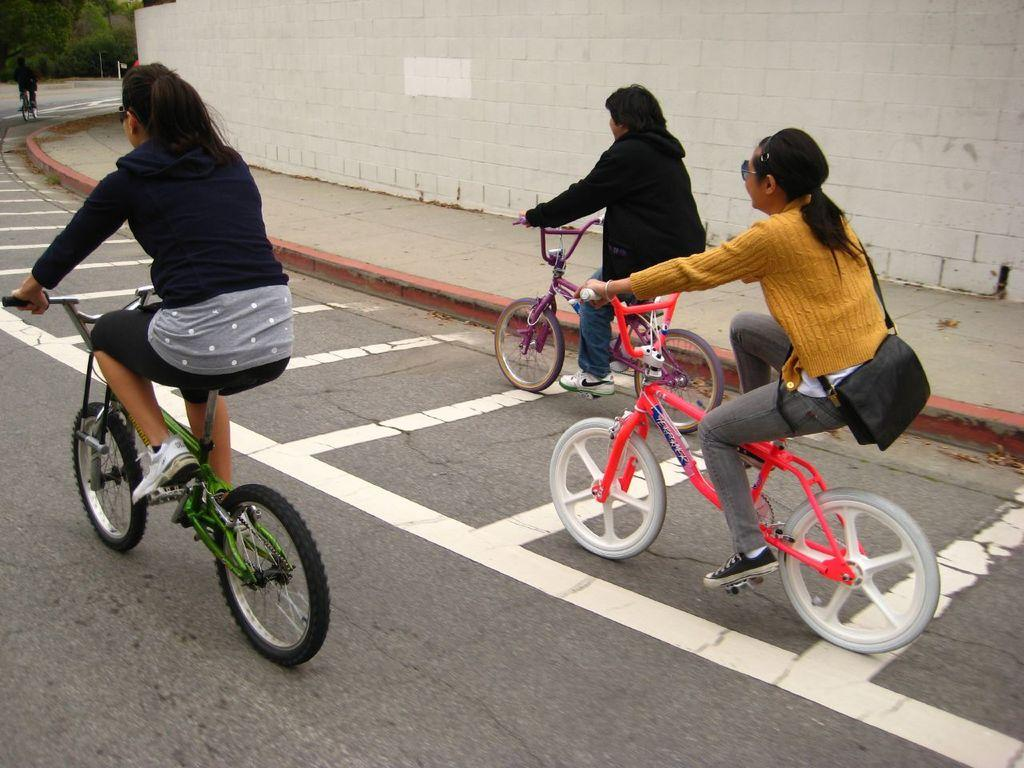How many people are on the bicycle in the image? There are three persons on the bicycle in the image. What is one of the persons doing while on the bicycle? One of the persons is carrying a bag. What type of surface can be seen in the image? There is a road in the image. What other structure is visible in the image? There is a wall in the image. What is the temperature like in the image? The provided facts do not mention the temperature or weather conditions, so it cannot be determined from the image. 